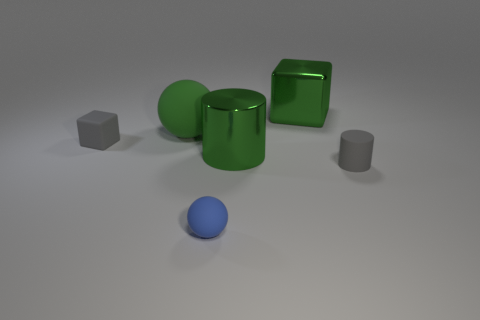How many other things are the same color as the tiny block?
Ensure brevity in your answer.  1. Is the number of things that are behind the tiny rubber cylinder the same as the number of rubber things?
Provide a short and direct response. Yes. How many gray rubber objects are on the left side of the gray thing that is behind the large object in front of the large green rubber sphere?
Your answer should be very brief. 0. Is the size of the blue ball the same as the green shiny object behind the large green sphere?
Your response must be concise. No. What number of tiny matte blocks are there?
Your answer should be very brief. 1. Do the gray object that is behind the shiny cylinder and the gray object right of the blue sphere have the same size?
Offer a very short reply. Yes. What color is the other thing that is the same shape as the small blue matte thing?
Provide a succinct answer. Green. Is the green matte object the same shape as the small blue rubber thing?
Offer a very short reply. Yes. There is another matte thing that is the same shape as the small blue object; what is its size?
Provide a short and direct response. Large. How many things have the same material as the big green sphere?
Keep it short and to the point. 3. 